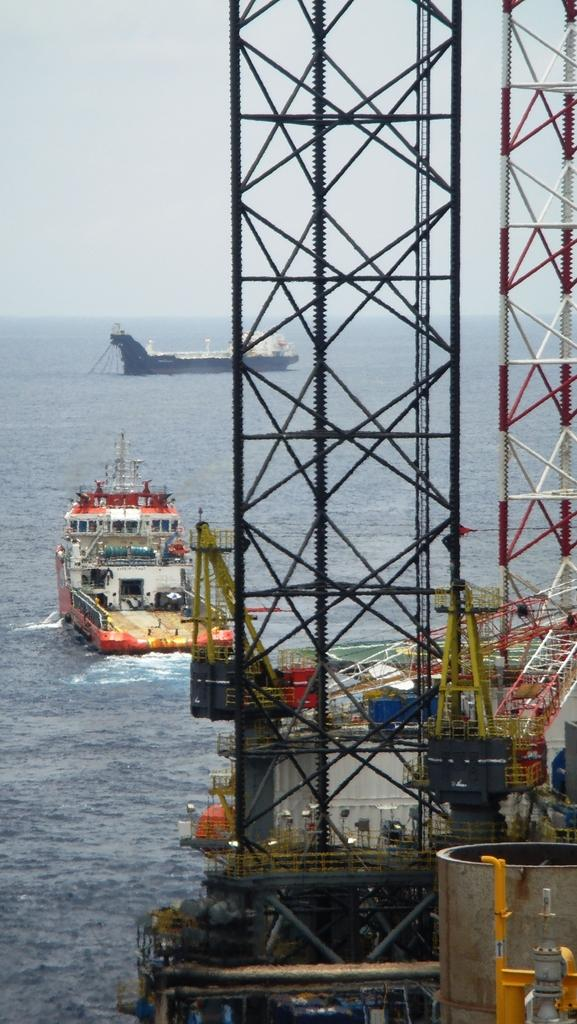What can be seen in the image that is related to transportation? There are two ships in the image. Where are the ships located? The ships are on the water. What is present on the right side of the image? There is a gas field on the right side of the image. What is visible at the top of the image? The sky is visible at the top of the image. What type of club is being used by the goat in the image? There is no goat or club present in the image. What book is the person reading in the image? There is no person reading a book in the image. 